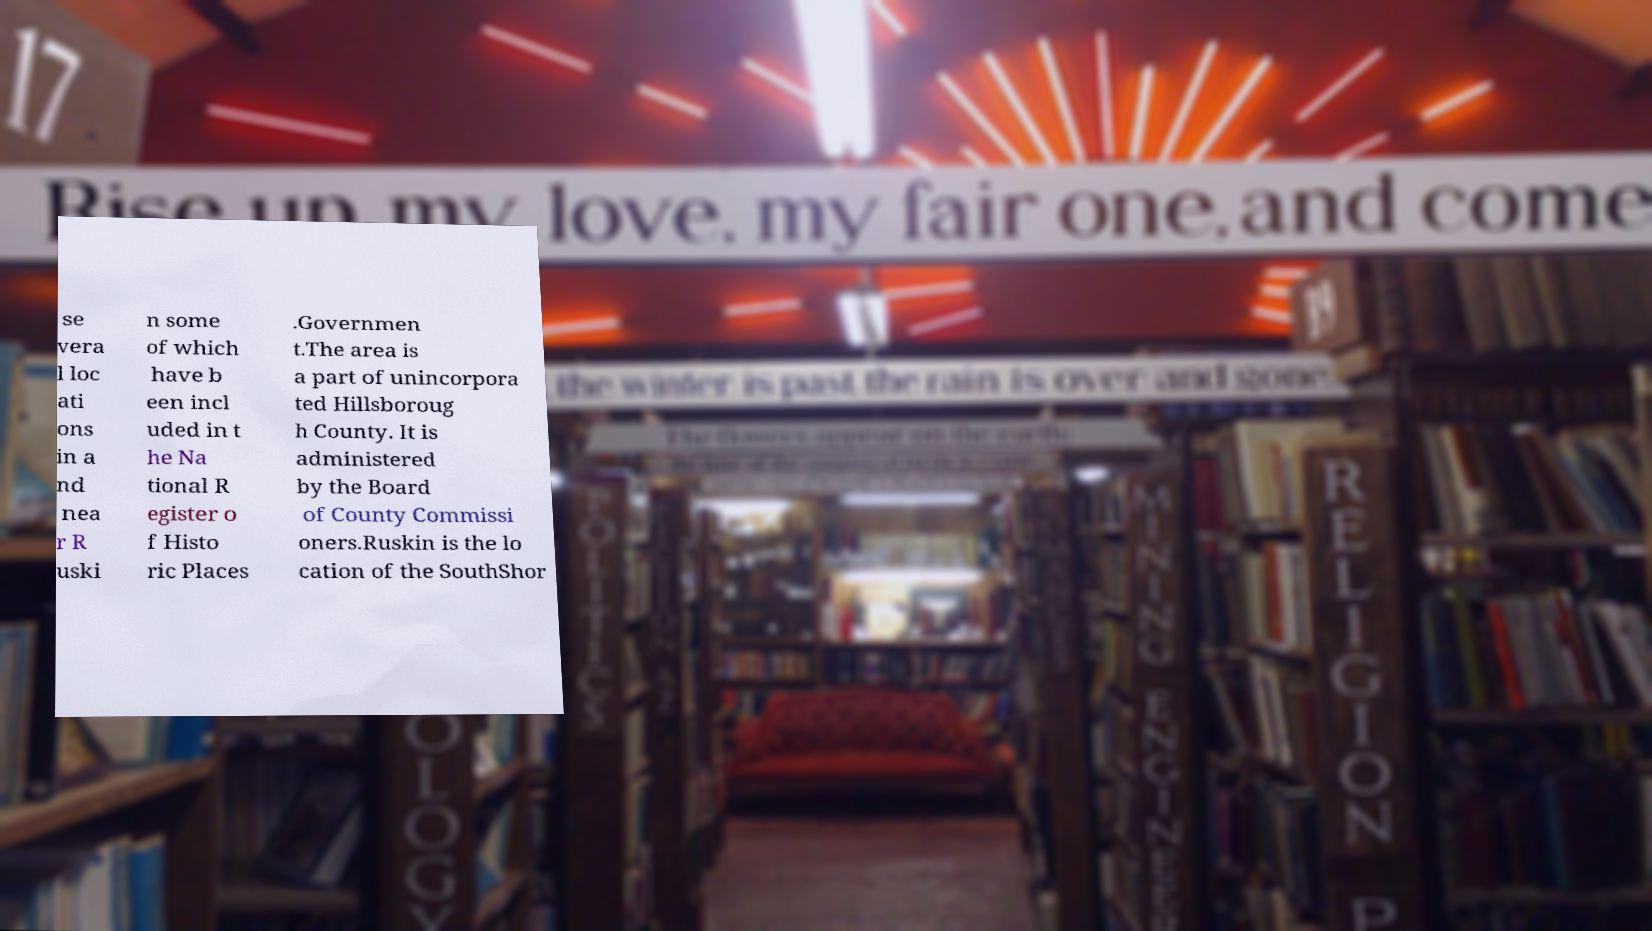I need the written content from this picture converted into text. Can you do that? se vera l loc ati ons in a nd nea r R uski n some of which have b een incl uded in t he Na tional R egister o f Histo ric Places .Governmen t.The area is a part of unincorpora ted Hillsboroug h County. It is administered by the Board of County Commissi oners.Ruskin is the lo cation of the SouthShor 